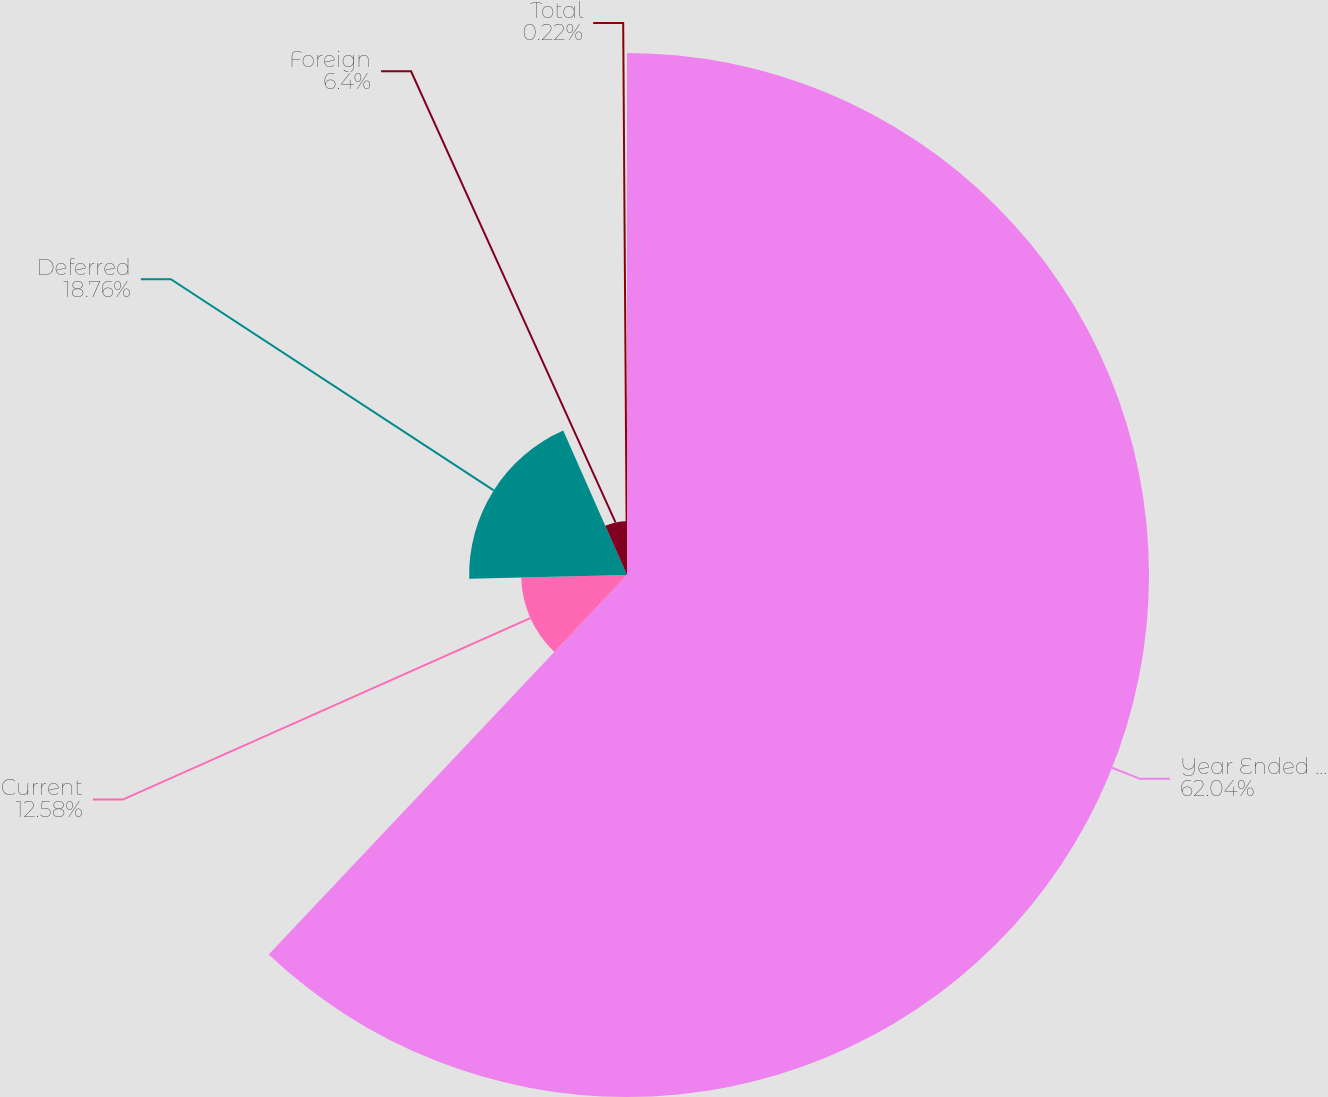Convert chart. <chart><loc_0><loc_0><loc_500><loc_500><pie_chart><fcel>Year Ended December 31<fcel>Current<fcel>Deferred<fcel>Foreign<fcel>Total<nl><fcel>62.04%<fcel>12.58%<fcel>18.76%<fcel>6.4%<fcel>0.22%<nl></chart> 